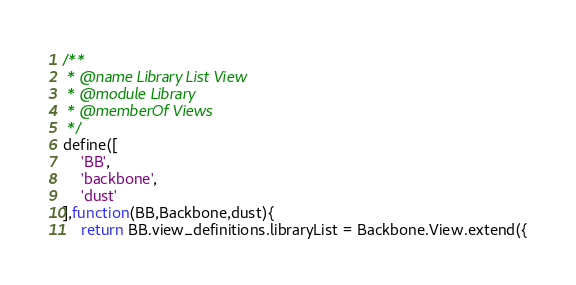<code> <loc_0><loc_0><loc_500><loc_500><_JavaScript_>/**
 * @name Library List View
 * @module Library
 * @memberOf Views
 */
define([
    'BB',
    'backbone',
    'dust'
],function(BB,Backbone,dust){
    return BB.view_definitions.libraryList = Backbone.View.extend({</code> 